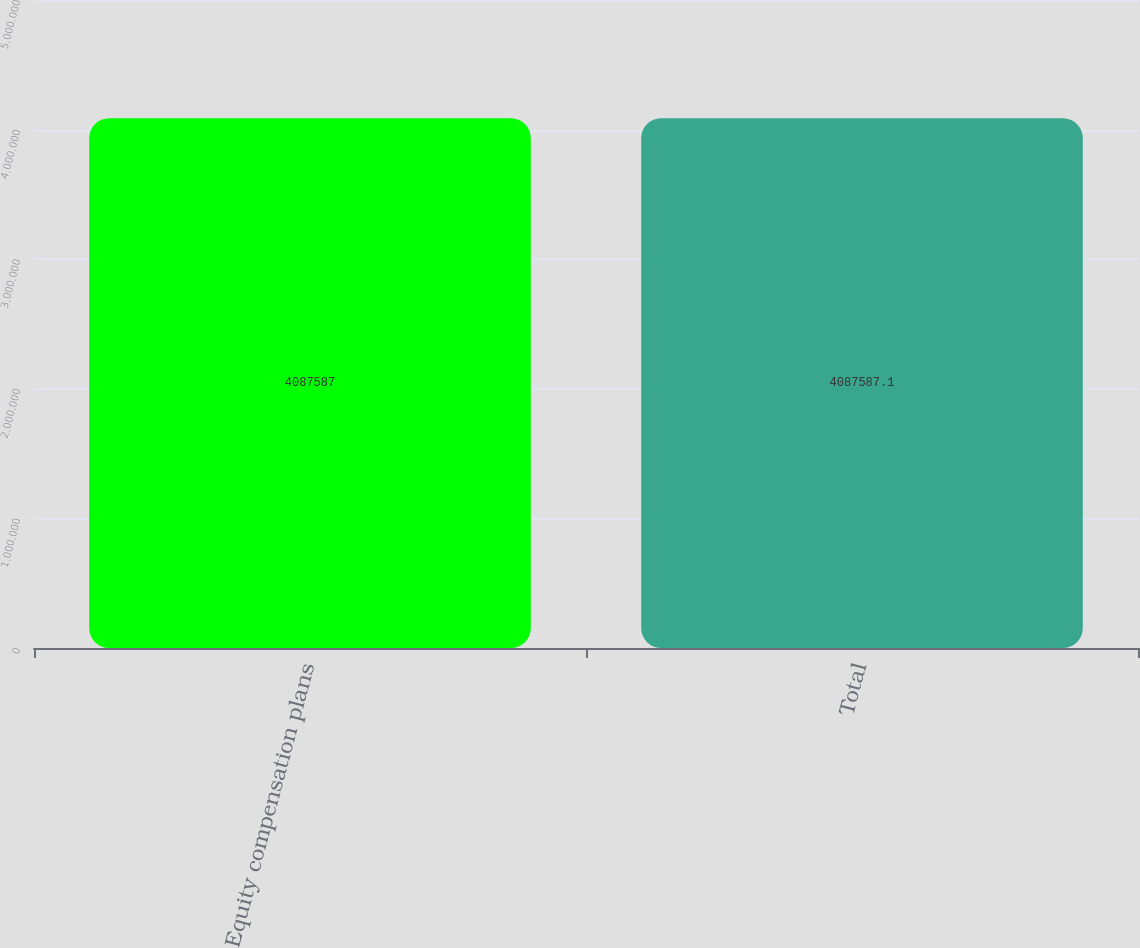Convert chart to OTSL. <chart><loc_0><loc_0><loc_500><loc_500><bar_chart><fcel>Equity compensation plans<fcel>Total<nl><fcel>4.08759e+06<fcel>4.08759e+06<nl></chart> 